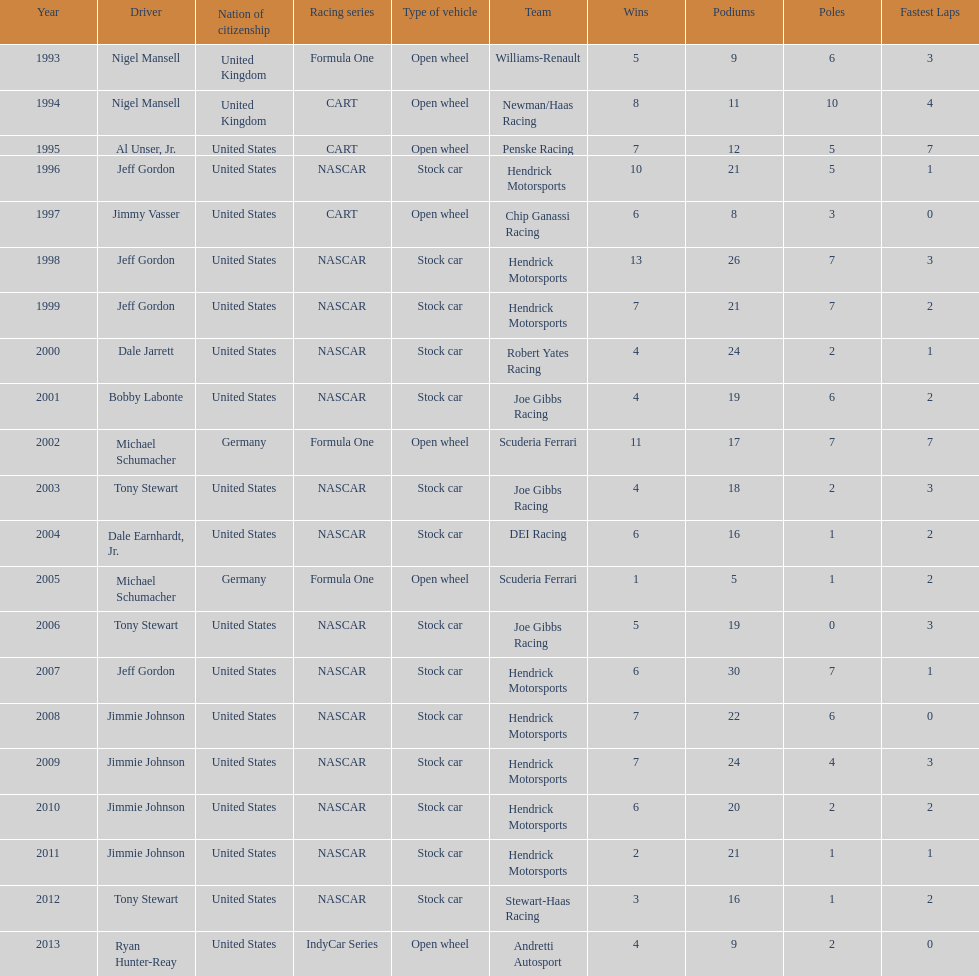Out of these drivers: nigel mansell, al unser, jr., michael schumacher, and jeff gordon, all but one has more than one espy award. who only has one espy award? Al Unser, Jr. 